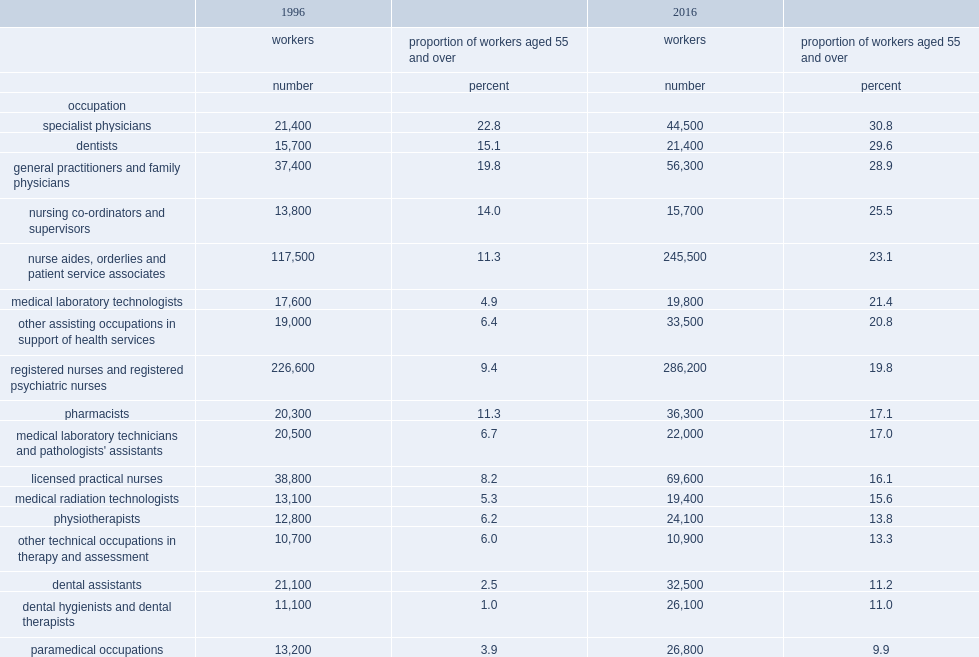What is the number of registered nurses and registered psychiatric nurses in 2016? 286200.0. What is the number of nurse aides, orderlies and patient service associates in 2016? 245500.0. 